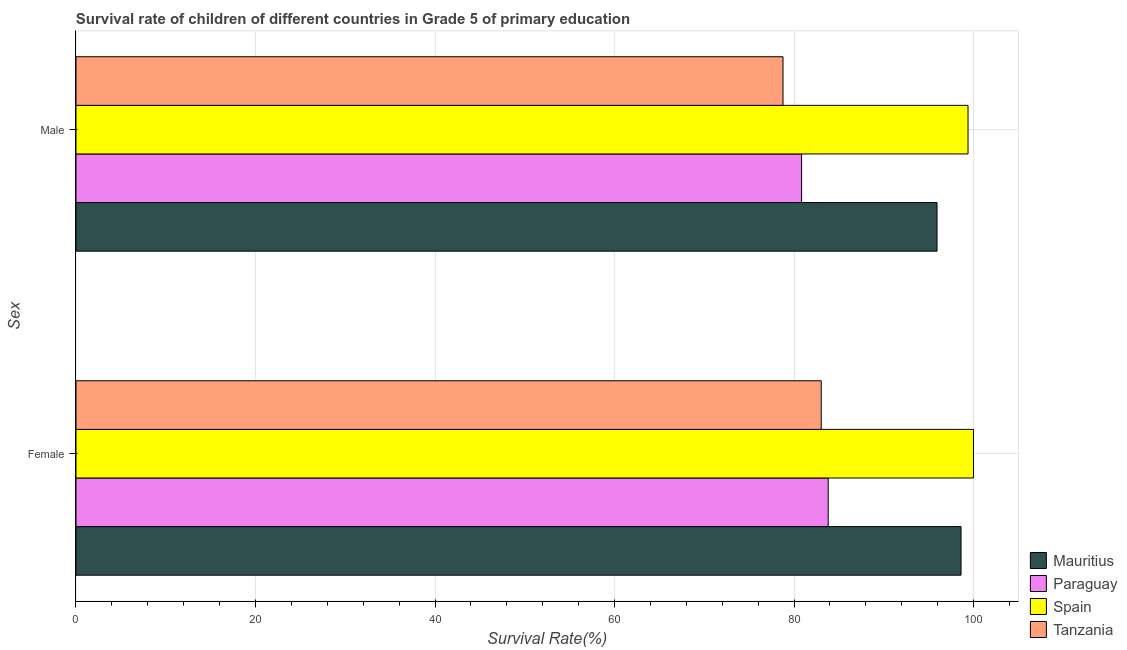How many different coloured bars are there?
Give a very brief answer. 4. Are the number of bars on each tick of the Y-axis equal?
Offer a very short reply. Yes. How many bars are there on the 1st tick from the top?
Provide a short and direct response. 4. What is the label of the 2nd group of bars from the top?
Provide a short and direct response. Female. What is the survival rate of male students in primary education in Spain?
Your answer should be very brief. 99.39. Across all countries, what is the maximum survival rate of female students in primary education?
Keep it short and to the point. 100. Across all countries, what is the minimum survival rate of female students in primary education?
Provide a succinct answer. 83.03. In which country was the survival rate of female students in primary education minimum?
Your response must be concise. Tanzania. What is the total survival rate of male students in primary education in the graph?
Keep it short and to the point. 354.94. What is the difference between the survival rate of male students in primary education in Tanzania and that in Mauritius?
Your answer should be very brief. -17.16. What is the difference between the survival rate of male students in primary education in Mauritius and the survival rate of female students in primary education in Tanzania?
Offer a very short reply. 12.9. What is the average survival rate of male students in primary education per country?
Your answer should be very brief. 88.74. What is the difference between the survival rate of male students in primary education and survival rate of female students in primary education in Spain?
Make the answer very short. -0.61. What is the ratio of the survival rate of female students in primary education in Paraguay to that in Tanzania?
Your response must be concise. 1.01. What does the 3rd bar from the top in Male represents?
Your answer should be compact. Paraguay. What does the 3rd bar from the bottom in Male represents?
Provide a succinct answer. Spain. How many countries are there in the graph?
Offer a very short reply. 4. What is the difference between two consecutive major ticks on the X-axis?
Give a very brief answer. 20. Does the graph contain any zero values?
Your response must be concise. No. What is the title of the graph?
Provide a succinct answer. Survival rate of children of different countries in Grade 5 of primary education. What is the label or title of the X-axis?
Ensure brevity in your answer.  Survival Rate(%). What is the label or title of the Y-axis?
Your answer should be compact. Sex. What is the Survival Rate(%) of Mauritius in Female?
Your answer should be compact. 98.61. What is the Survival Rate(%) of Paraguay in Female?
Make the answer very short. 83.81. What is the Survival Rate(%) of Spain in Female?
Offer a very short reply. 100. What is the Survival Rate(%) in Tanzania in Female?
Make the answer very short. 83.03. What is the Survival Rate(%) in Mauritius in Male?
Make the answer very short. 95.94. What is the Survival Rate(%) of Paraguay in Male?
Ensure brevity in your answer.  80.84. What is the Survival Rate(%) of Spain in Male?
Keep it short and to the point. 99.39. What is the Survival Rate(%) in Tanzania in Male?
Your answer should be compact. 78.78. Across all Sex, what is the maximum Survival Rate(%) in Mauritius?
Ensure brevity in your answer.  98.61. Across all Sex, what is the maximum Survival Rate(%) of Paraguay?
Give a very brief answer. 83.81. Across all Sex, what is the maximum Survival Rate(%) in Spain?
Offer a very short reply. 100. Across all Sex, what is the maximum Survival Rate(%) of Tanzania?
Ensure brevity in your answer.  83.03. Across all Sex, what is the minimum Survival Rate(%) of Mauritius?
Provide a succinct answer. 95.94. Across all Sex, what is the minimum Survival Rate(%) in Paraguay?
Provide a short and direct response. 80.84. Across all Sex, what is the minimum Survival Rate(%) of Spain?
Your response must be concise. 99.39. Across all Sex, what is the minimum Survival Rate(%) in Tanzania?
Offer a terse response. 78.78. What is the total Survival Rate(%) of Mauritius in the graph?
Your answer should be very brief. 194.55. What is the total Survival Rate(%) in Paraguay in the graph?
Provide a succinct answer. 164.65. What is the total Survival Rate(%) in Spain in the graph?
Provide a succinct answer. 199.39. What is the total Survival Rate(%) of Tanzania in the graph?
Your answer should be compact. 161.81. What is the difference between the Survival Rate(%) in Mauritius in Female and that in Male?
Offer a terse response. 2.67. What is the difference between the Survival Rate(%) of Paraguay in Female and that in Male?
Your answer should be compact. 2.96. What is the difference between the Survival Rate(%) in Spain in Female and that in Male?
Offer a very short reply. 0.61. What is the difference between the Survival Rate(%) in Tanzania in Female and that in Male?
Keep it short and to the point. 4.26. What is the difference between the Survival Rate(%) in Mauritius in Female and the Survival Rate(%) in Paraguay in Male?
Your answer should be compact. 17.77. What is the difference between the Survival Rate(%) of Mauritius in Female and the Survival Rate(%) of Spain in Male?
Your response must be concise. -0.78. What is the difference between the Survival Rate(%) of Mauritius in Female and the Survival Rate(%) of Tanzania in Male?
Ensure brevity in your answer.  19.83. What is the difference between the Survival Rate(%) of Paraguay in Female and the Survival Rate(%) of Spain in Male?
Offer a terse response. -15.58. What is the difference between the Survival Rate(%) in Paraguay in Female and the Survival Rate(%) in Tanzania in Male?
Ensure brevity in your answer.  5.03. What is the difference between the Survival Rate(%) of Spain in Female and the Survival Rate(%) of Tanzania in Male?
Your answer should be very brief. 21.22. What is the average Survival Rate(%) in Mauritius per Sex?
Your answer should be very brief. 97.27. What is the average Survival Rate(%) of Paraguay per Sex?
Ensure brevity in your answer.  82.33. What is the average Survival Rate(%) of Spain per Sex?
Offer a terse response. 99.69. What is the average Survival Rate(%) in Tanzania per Sex?
Offer a very short reply. 80.9. What is the difference between the Survival Rate(%) in Mauritius and Survival Rate(%) in Paraguay in Female?
Your answer should be very brief. 14.8. What is the difference between the Survival Rate(%) in Mauritius and Survival Rate(%) in Spain in Female?
Keep it short and to the point. -1.39. What is the difference between the Survival Rate(%) of Mauritius and Survival Rate(%) of Tanzania in Female?
Ensure brevity in your answer.  15.58. What is the difference between the Survival Rate(%) in Paraguay and Survival Rate(%) in Spain in Female?
Your response must be concise. -16.19. What is the difference between the Survival Rate(%) in Paraguay and Survival Rate(%) in Tanzania in Female?
Give a very brief answer. 0.78. What is the difference between the Survival Rate(%) of Spain and Survival Rate(%) of Tanzania in Female?
Give a very brief answer. 16.96. What is the difference between the Survival Rate(%) in Mauritius and Survival Rate(%) in Paraguay in Male?
Keep it short and to the point. 15.09. What is the difference between the Survival Rate(%) in Mauritius and Survival Rate(%) in Spain in Male?
Keep it short and to the point. -3.45. What is the difference between the Survival Rate(%) in Mauritius and Survival Rate(%) in Tanzania in Male?
Keep it short and to the point. 17.16. What is the difference between the Survival Rate(%) of Paraguay and Survival Rate(%) of Spain in Male?
Offer a very short reply. -18.54. What is the difference between the Survival Rate(%) of Paraguay and Survival Rate(%) of Tanzania in Male?
Make the answer very short. 2.07. What is the difference between the Survival Rate(%) in Spain and Survival Rate(%) in Tanzania in Male?
Offer a terse response. 20.61. What is the ratio of the Survival Rate(%) in Mauritius in Female to that in Male?
Keep it short and to the point. 1.03. What is the ratio of the Survival Rate(%) in Paraguay in Female to that in Male?
Your answer should be compact. 1.04. What is the ratio of the Survival Rate(%) in Tanzania in Female to that in Male?
Your response must be concise. 1.05. What is the difference between the highest and the second highest Survival Rate(%) in Mauritius?
Your answer should be very brief. 2.67. What is the difference between the highest and the second highest Survival Rate(%) of Paraguay?
Give a very brief answer. 2.96. What is the difference between the highest and the second highest Survival Rate(%) of Spain?
Your answer should be compact. 0.61. What is the difference between the highest and the second highest Survival Rate(%) of Tanzania?
Give a very brief answer. 4.26. What is the difference between the highest and the lowest Survival Rate(%) of Mauritius?
Your answer should be compact. 2.67. What is the difference between the highest and the lowest Survival Rate(%) in Paraguay?
Ensure brevity in your answer.  2.96. What is the difference between the highest and the lowest Survival Rate(%) of Spain?
Offer a terse response. 0.61. What is the difference between the highest and the lowest Survival Rate(%) of Tanzania?
Keep it short and to the point. 4.26. 